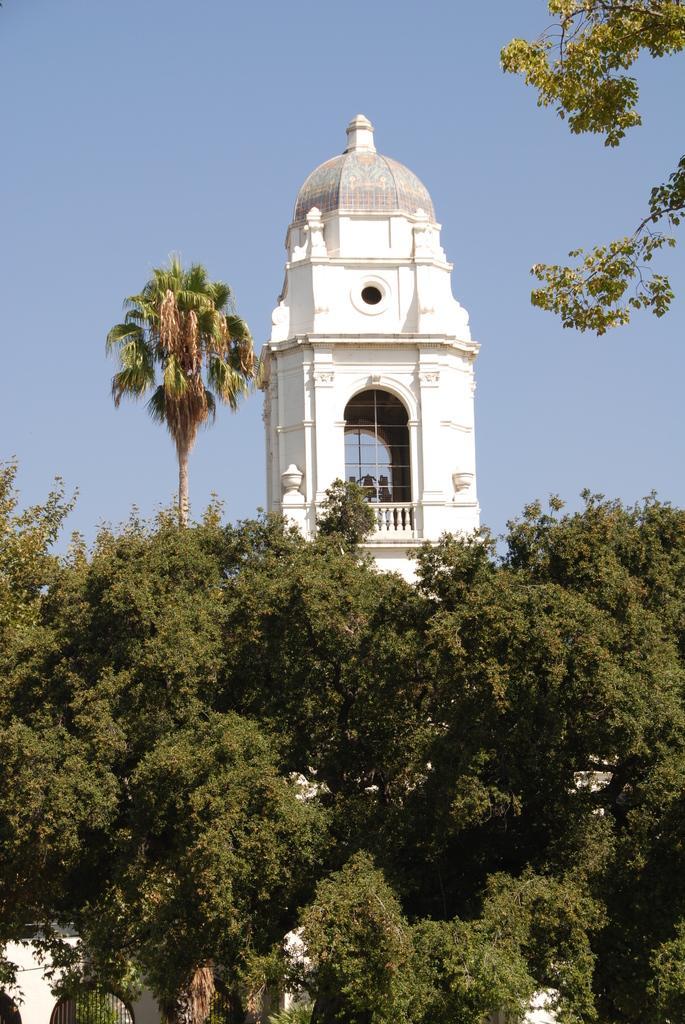Please provide a concise description of this image. This picture is clicked the outside. In the foreground we can see the trees and the building. In the center we can see the tower. In the background we can see the sky. 